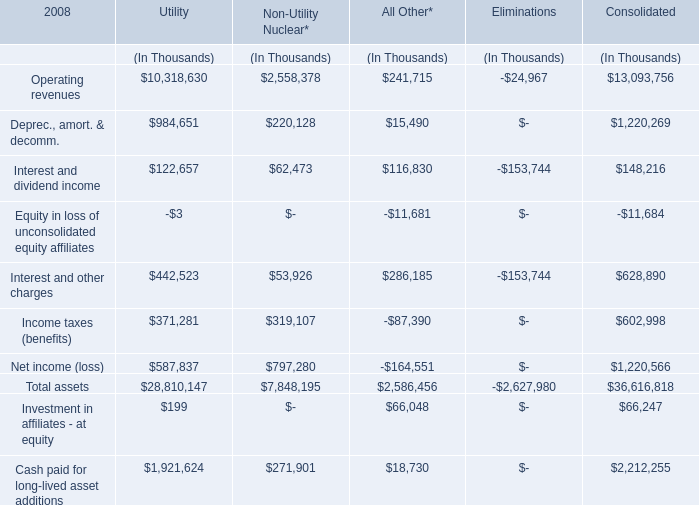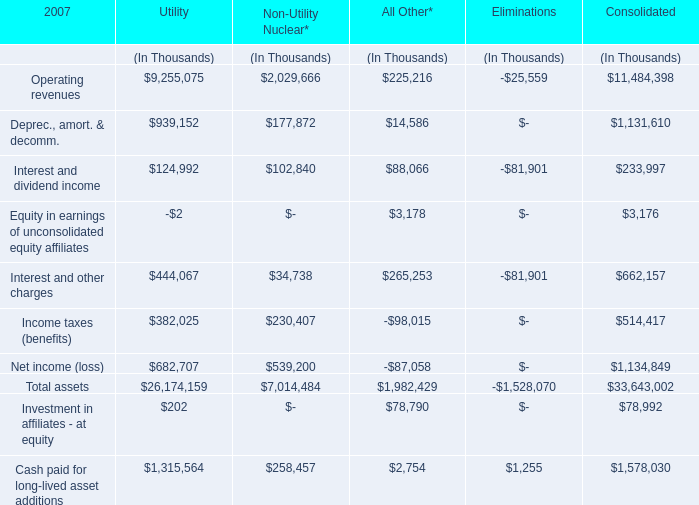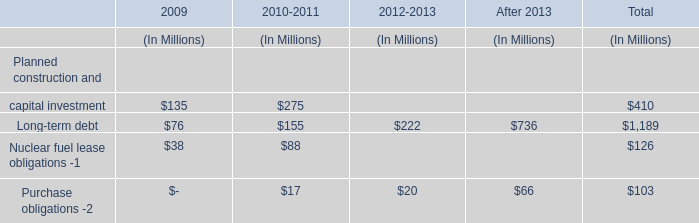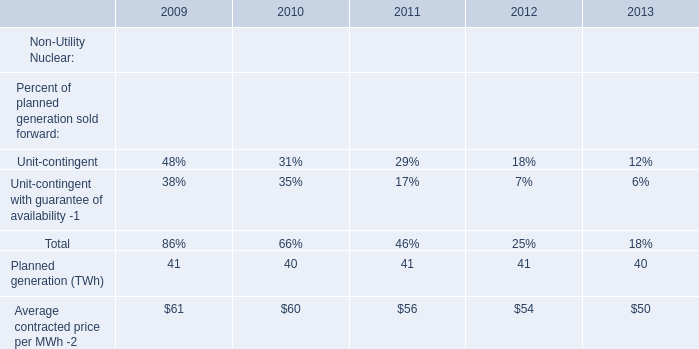What's the total value of all Utility that are smaller than 0 in 2008? (in Thousand) 
Answer: -3.0. 